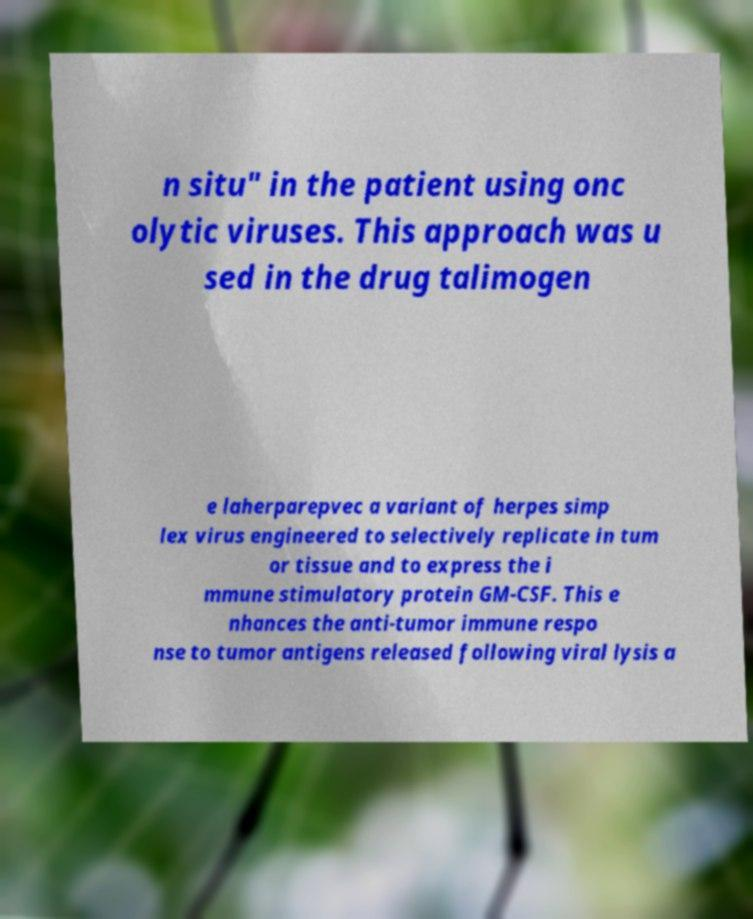For documentation purposes, I need the text within this image transcribed. Could you provide that? n situ" in the patient using onc olytic viruses. This approach was u sed in the drug talimogen e laherparepvec a variant of herpes simp lex virus engineered to selectively replicate in tum or tissue and to express the i mmune stimulatory protein GM-CSF. This e nhances the anti-tumor immune respo nse to tumor antigens released following viral lysis a 